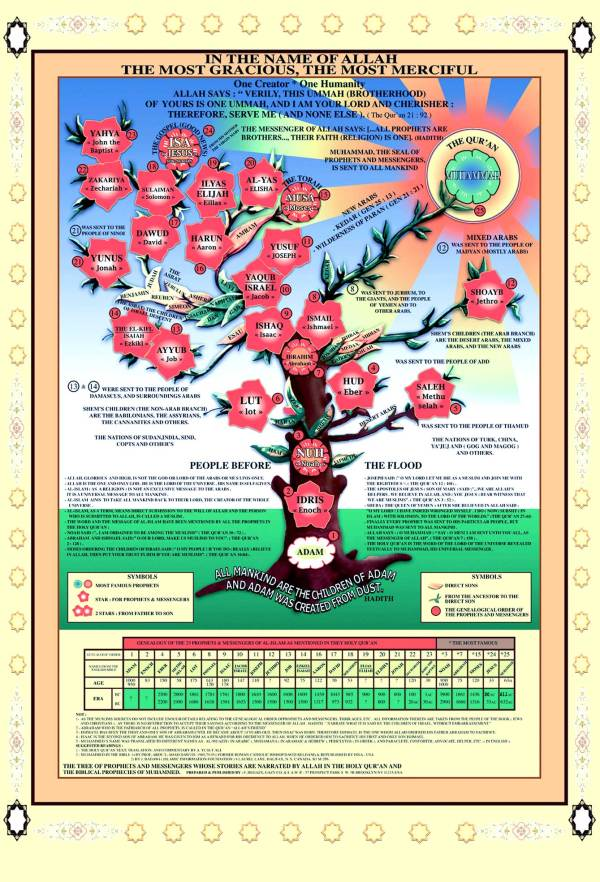Can you determine the relationship between the prophets based on their positioning on the tree and the text surrounding them? The visual arrangement of the prophets on this tree, coupled with the surrounding text, suggests a meticulous depiction of their genealogical and spiritual lineage within Islamic tradition. Prophets are not just randomly positioned; rather, each placement and the connecting lines represent their historical or theological connections. Adam, located at the root, signifies the origin of humanity and prophethood. As branches radiate upwards, subsequent prophets appear, illustrating a sequence that often correlates with their appearance in religious texts. Higher positions for prophets like Muhammad denote a culmination of prophetic tradition, symbolizing a comprehensive and final conveyance of divine messages. The branching could also imply the spread of messages to different regions and peoples, reflecting the diverse but interconnected nature of prophetic missions in Islam. 